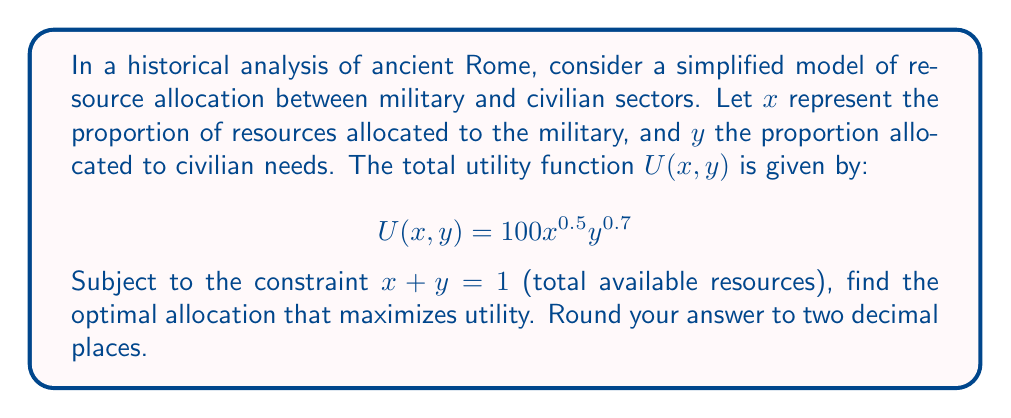Show me your answer to this math problem. To solve this optimization problem, we'll use the method of Lagrange multipliers:

1) Define the Lagrangian function:
   $$L(x,y,\lambda) = 100x^{0.5}y^{0.7} - \lambda(x + y - 1)$$

2) Take partial derivatives and set them equal to zero:
   $$\frac{\partial L}{\partial x} = 50x^{-0.5}y^{0.7} - \lambda = 0$$
   $$\frac{\partial L}{\partial y} = 70x^{0.5}y^{-0.3} - \lambda = 0$$
   $$\frac{\partial L}{\partial \lambda} = x + y - 1 = 0$$

3) From the first two equations:
   $$50x^{-0.5}y^{0.7} = 70x^{0.5}y^{-0.3}$$

4) Simplify:
   $$\frac{5}{7} = \frac{x}{y}$$

5) Substitute into the constraint equation:
   $$x + y = 1$$
   $$\frac{5}{7}y + y = 1$$
   $$\frac{12}{7}y = 1$$
   $$y = \frac{7}{12} \approx 0.58$$

6) Solve for x:
   $$x = 1 - y = 1 - \frac{7}{12} = \frac{5}{12} \approx 0.42$$

Therefore, the optimal allocation is approximately 42% to military and 58% to civilian needs.
Answer: $(0.42, 0.58)$ 